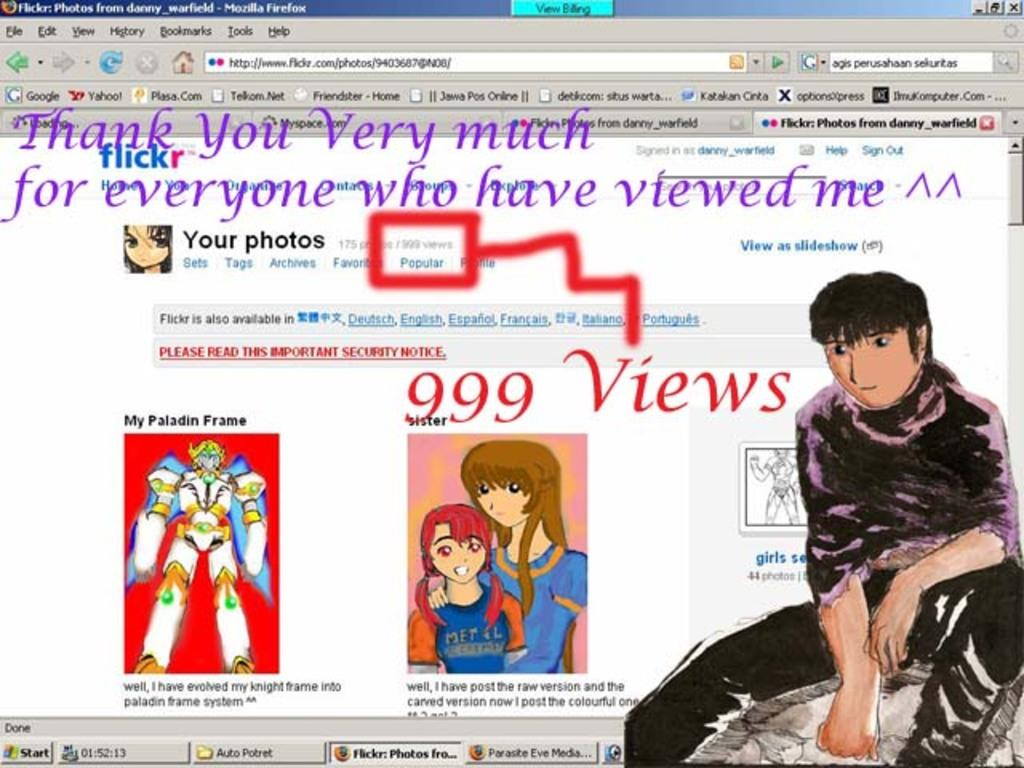What is the main subject of the image? The main subject of the image is a picture of a screen. What elements can be seen on the screen? There are icons, pictures, folders, links, and letters on the screen. What type of crate is visible in the image? There is no crate present in the image; it features a picture of a screen with various elements on it. Are there any police officers visible in the image? There are no police officers present in the image; it features a picture of a screen with various elements on it. 